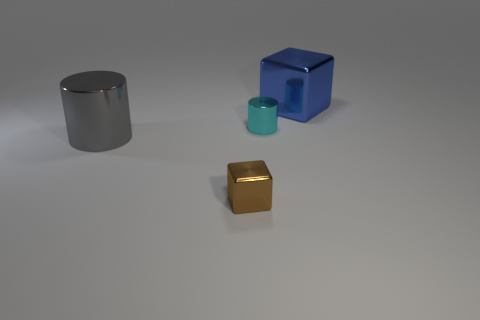What purpose do these objects serve? It's not clear what their intended purpose is from the image alone. They may be part of a visual study or serve as placeholders in a rendering to demonstrate lighting and material effects in a three-dimensional space. 